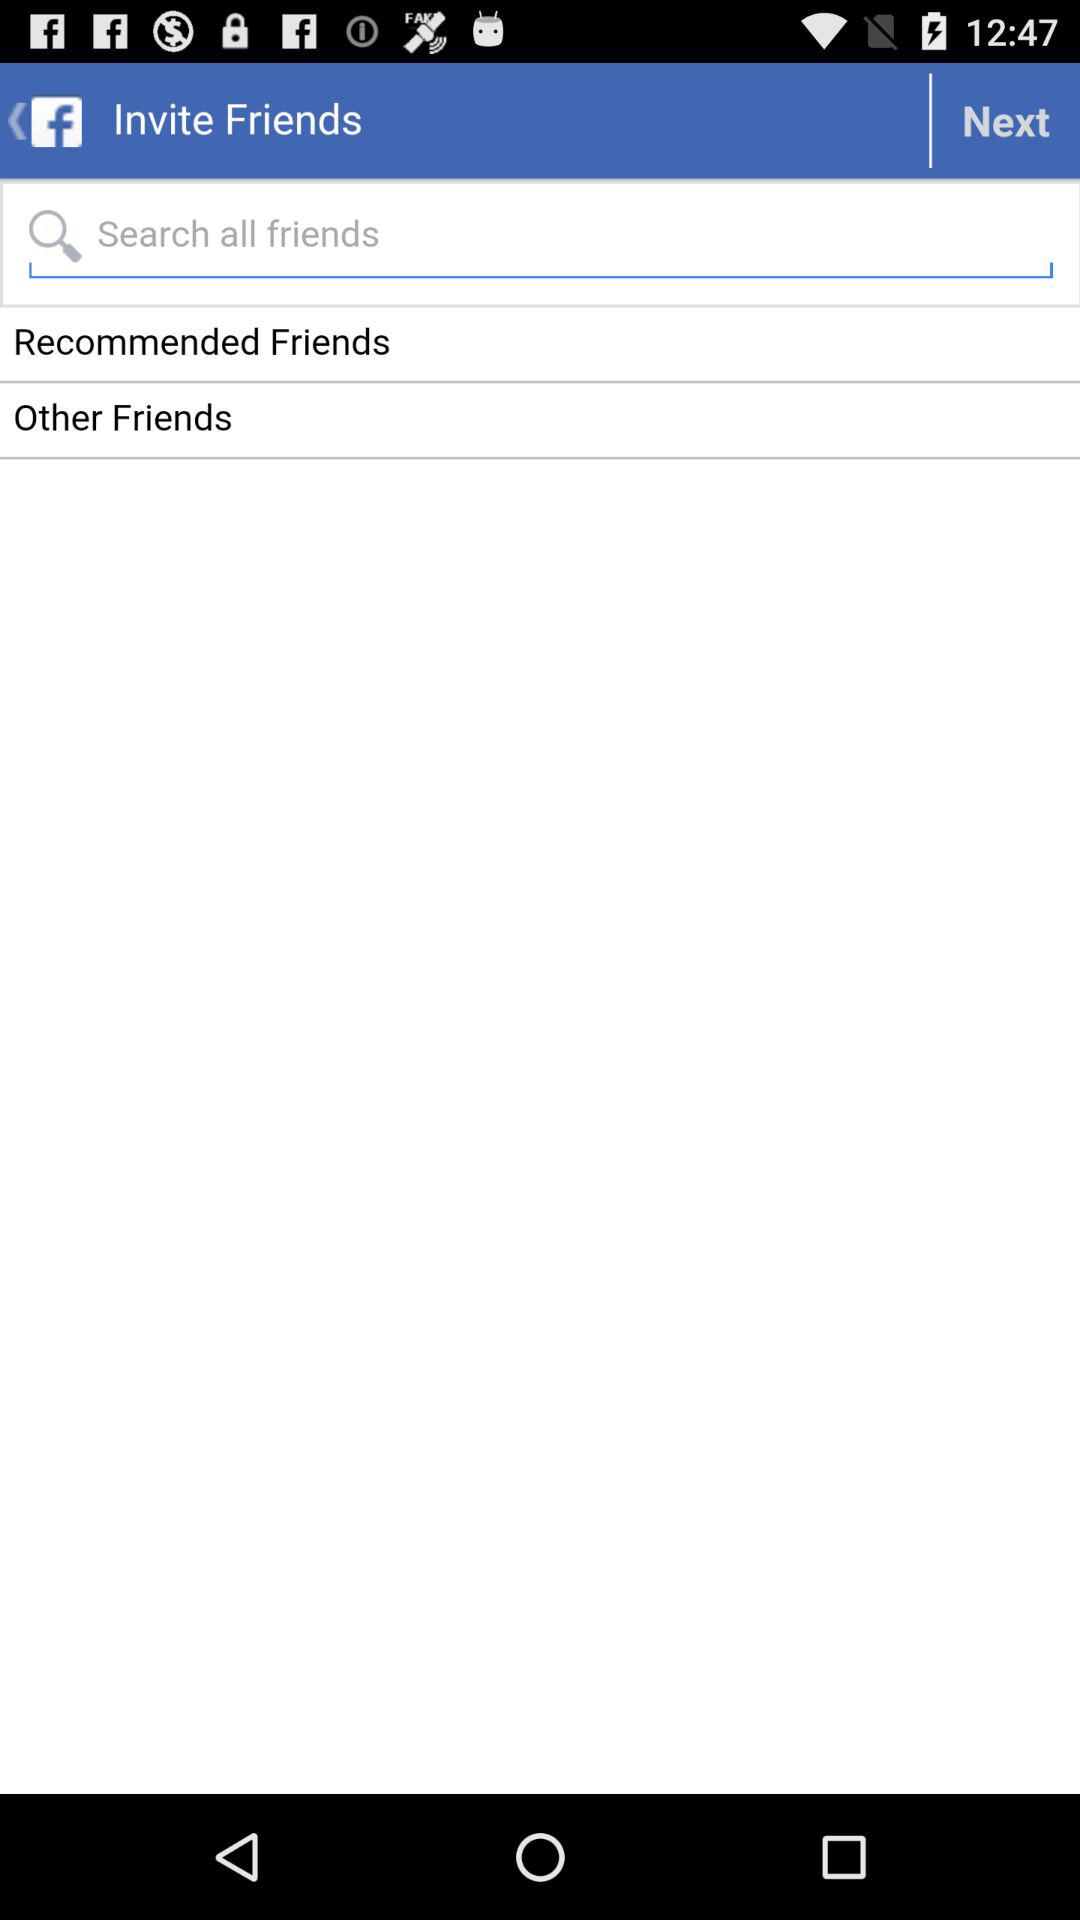What application will receive the public profile and email address? The public profile and email address will be received by "ChefsFeed". 